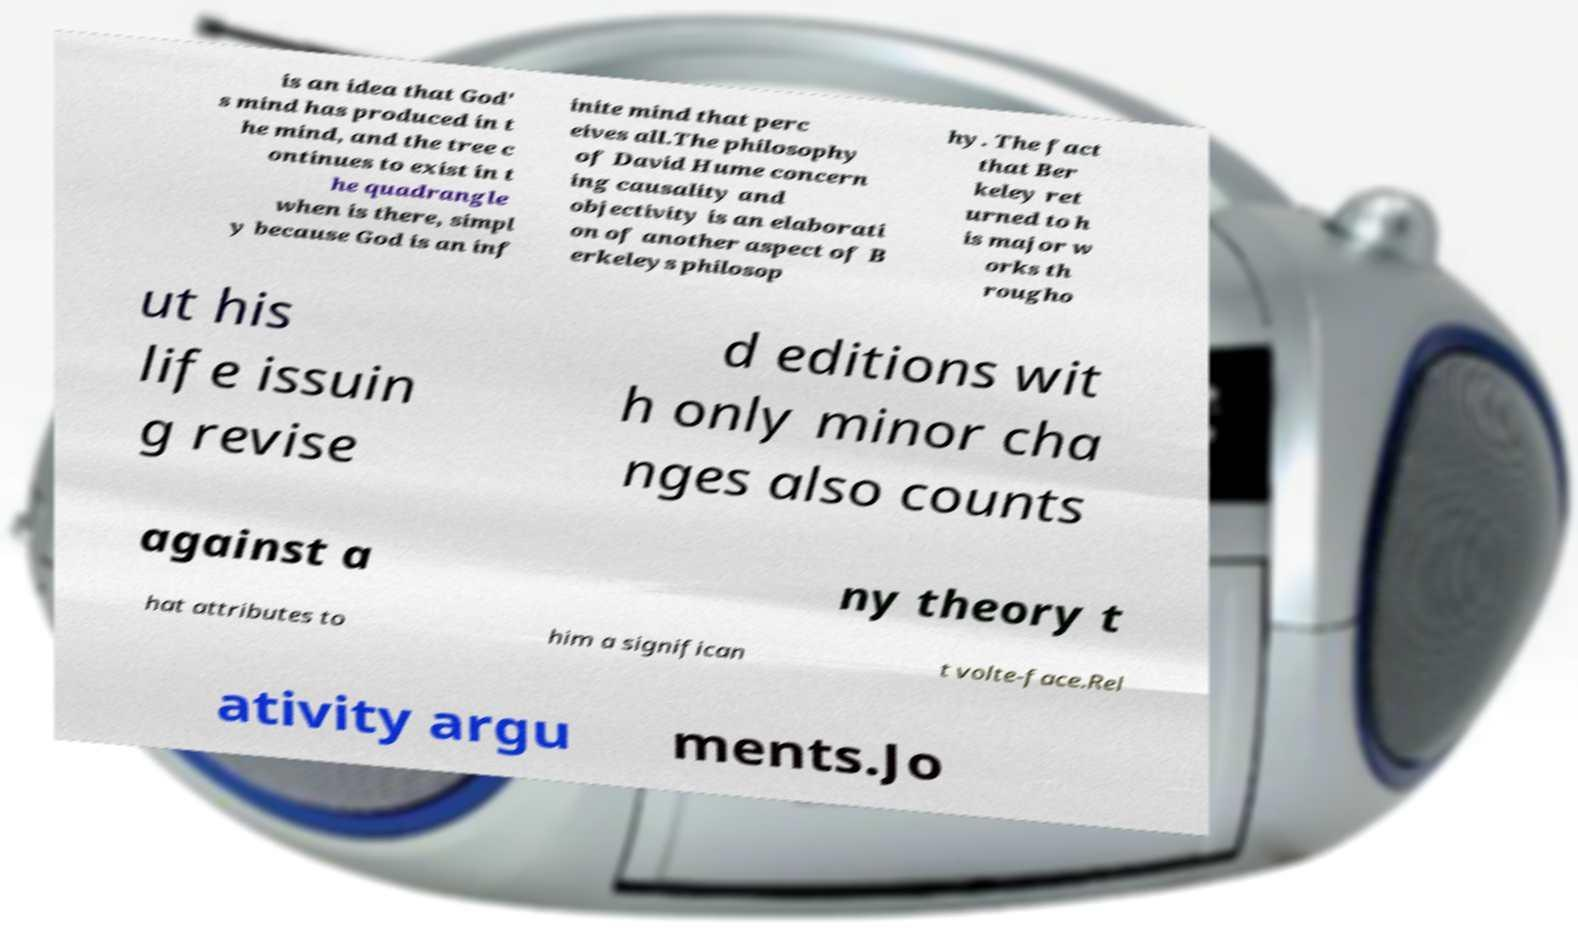For documentation purposes, I need the text within this image transcribed. Could you provide that? is an idea that God' s mind has produced in t he mind, and the tree c ontinues to exist in t he quadrangle when is there, simpl y because God is an inf inite mind that perc eives all.The philosophy of David Hume concern ing causality and objectivity is an elaborati on of another aspect of B erkeleys philosop hy. The fact that Ber keley ret urned to h is major w orks th rougho ut his life issuin g revise d editions wit h only minor cha nges also counts against a ny theory t hat attributes to him a significan t volte-face.Rel ativity argu ments.Jo 